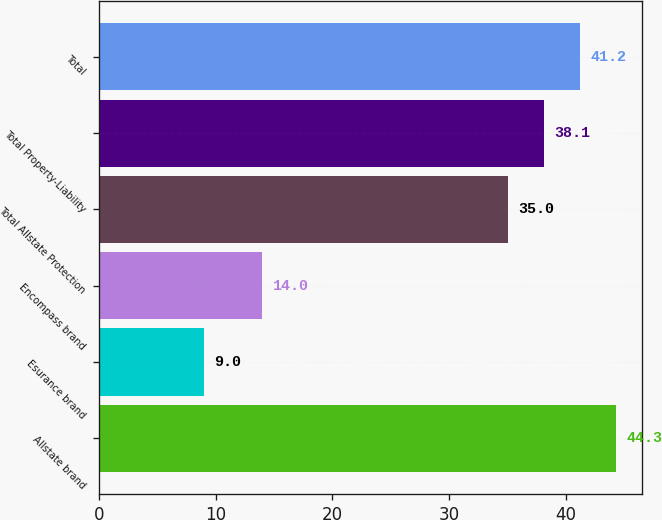<chart> <loc_0><loc_0><loc_500><loc_500><bar_chart><fcel>Allstate brand<fcel>Esurance brand<fcel>Encompass brand<fcel>Total Allstate Protection<fcel>Total Property-Liability<fcel>Total<nl><fcel>44.3<fcel>9<fcel>14<fcel>35<fcel>38.1<fcel>41.2<nl></chart> 